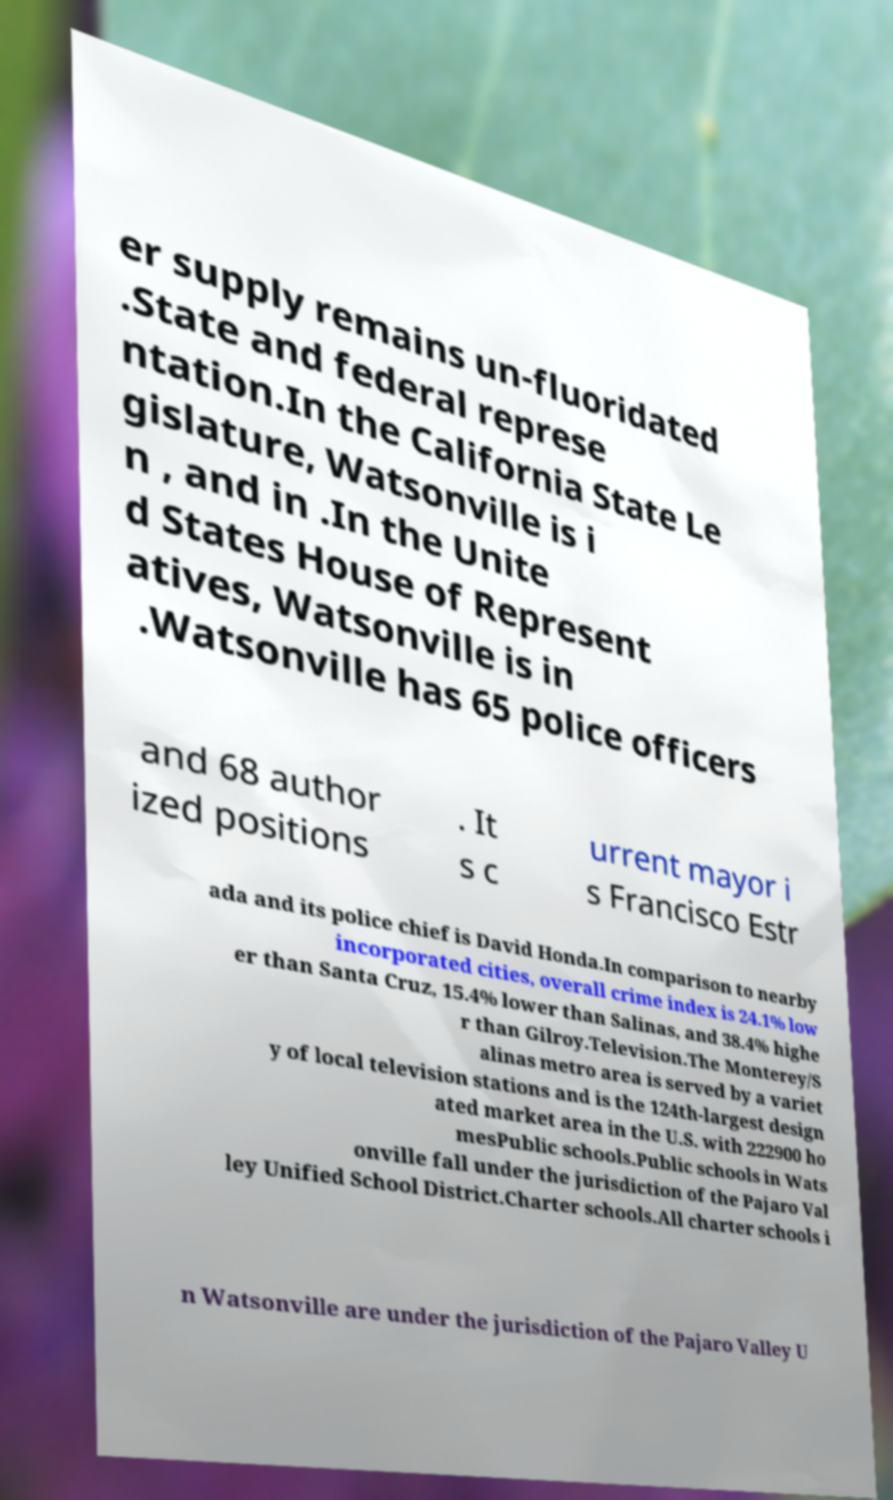There's text embedded in this image that I need extracted. Can you transcribe it verbatim? er supply remains un-fluoridated .State and federal represe ntation.In the California State Le gislature, Watsonville is i n , and in .In the Unite d States House of Represent atives, Watsonville is in .Watsonville has 65 police officers and 68 author ized positions . It s c urrent mayor i s Francisco Estr ada and its police chief is David Honda.In comparison to nearby incorporated cities, overall crime index is 24.1% low er than Santa Cruz, 15.4% lower than Salinas, and 38.4% highe r than Gilroy.Television.The Monterey/S alinas metro area is served by a variet y of local television stations and is the 124th-largest design ated market area in the U.S. with 222900 ho mesPublic schools.Public schools in Wats onville fall under the jurisdiction of the Pajaro Val ley Unified School District.Charter schools.All charter schools i n Watsonville are under the jurisdiction of the Pajaro Valley U 